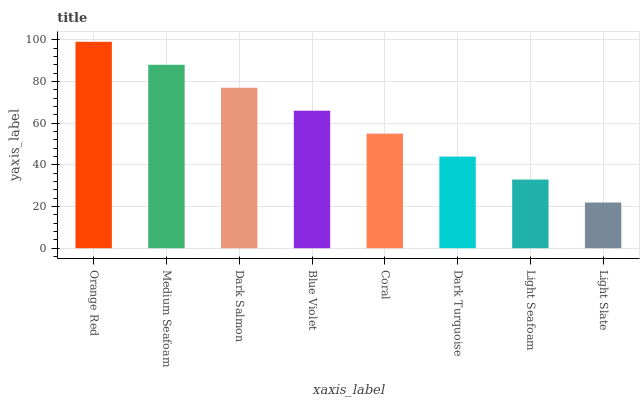Is Light Slate the minimum?
Answer yes or no. Yes. Is Orange Red the maximum?
Answer yes or no. Yes. Is Medium Seafoam the minimum?
Answer yes or no. No. Is Medium Seafoam the maximum?
Answer yes or no. No. Is Orange Red greater than Medium Seafoam?
Answer yes or no. Yes. Is Medium Seafoam less than Orange Red?
Answer yes or no. Yes. Is Medium Seafoam greater than Orange Red?
Answer yes or no. No. Is Orange Red less than Medium Seafoam?
Answer yes or no. No. Is Blue Violet the high median?
Answer yes or no. Yes. Is Coral the low median?
Answer yes or no. Yes. Is Light Slate the high median?
Answer yes or no. No. Is Dark Turquoise the low median?
Answer yes or no. No. 